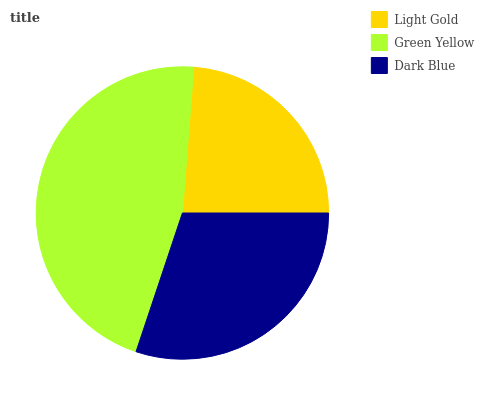Is Light Gold the minimum?
Answer yes or no. Yes. Is Green Yellow the maximum?
Answer yes or no. Yes. Is Dark Blue the minimum?
Answer yes or no. No. Is Dark Blue the maximum?
Answer yes or no. No. Is Green Yellow greater than Dark Blue?
Answer yes or no. Yes. Is Dark Blue less than Green Yellow?
Answer yes or no. Yes. Is Dark Blue greater than Green Yellow?
Answer yes or no. No. Is Green Yellow less than Dark Blue?
Answer yes or no. No. Is Dark Blue the high median?
Answer yes or no. Yes. Is Dark Blue the low median?
Answer yes or no. Yes. Is Light Gold the high median?
Answer yes or no. No. Is Green Yellow the low median?
Answer yes or no. No. 